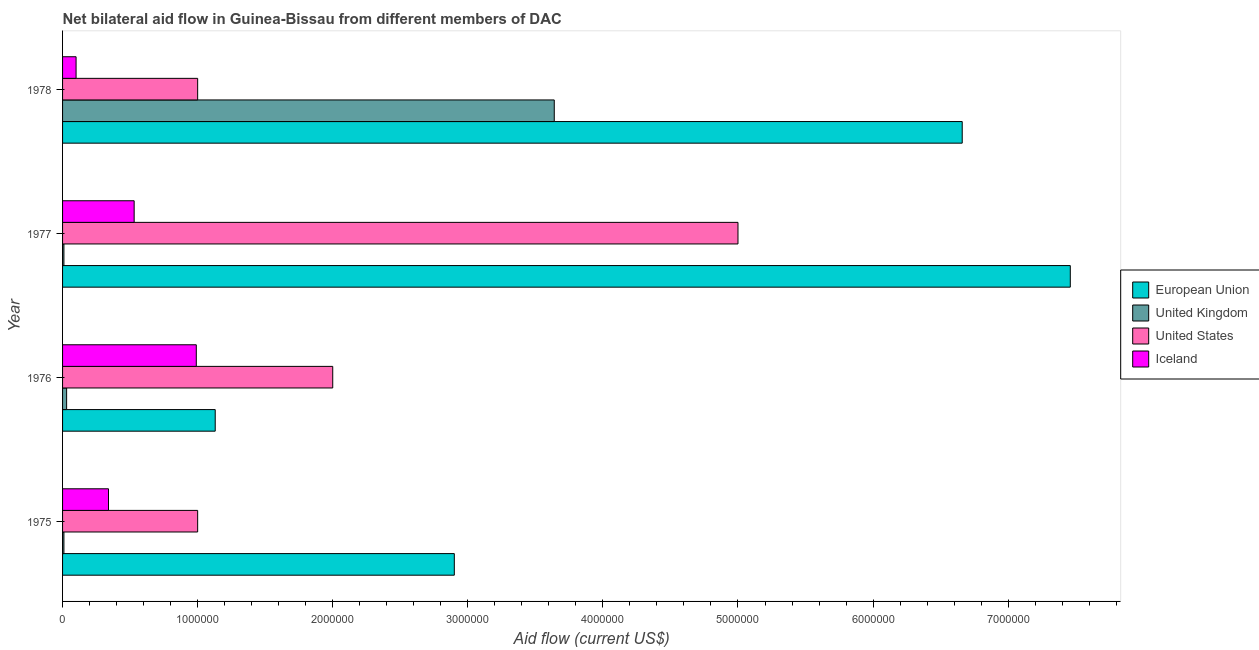How many different coloured bars are there?
Keep it short and to the point. 4. Are the number of bars per tick equal to the number of legend labels?
Keep it short and to the point. Yes. Are the number of bars on each tick of the Y-axis equal?
Make the answer very short. Yes. How many bars are there on the 1st tick from the top?
Make the answer very short. 4. How many bars are there on the 3rd tick from the bottom?
Your answer should be very brief. 4. What is the label of the 3rd group of bars from the top?
Your response must be concise. 1976. What is the amount of aid given by uk in 1975?
Ensure brevity in your answer.  10000. Across all years, what is the maximum amount of aid given by eu?
Your answer should be compact. 7.46e+06. Across all years, what is the minimum amount of aid given by us?
Offer a very short reply. 1.00e+06. In which year was the amount of aid given by uk maximum?
Offer a very short reply. 1978. In which year was the amount of aid given by uk minimum?
Ensure brevity in your answer.  1975. What is the total amount of aid given by eu in the graph?
Offer a terse response. 1.82e+07. What is the difference between the amount of aid given by us in 1977 and that in 1978?
Provide a succinct answer. 4.00e+06. What is the difference between the amount of aid given by eu in 1977 and the amount of aid given by iceland in 1978?
Your answer should be compact. 7.36e+06. In the year 1976, what is the difference between the amount of aid given by us and amount of aid given by eu?
Your answer should be very brief. 8.70e+05. What is the ratio of the amount of aid given by uk in 1977 to that in 1978?
Offer a very short reply. 0. Is the difference between the amount of aid given by uk in 1976 and 1977 greater than the difference between the amount of aid given by iceland in 1976 and 1977?
Keep it short and to the point. No. What is the difference between the highest and the second highest amount of aid given by us?
Provide a succinct answer. 3.00e+06. What is the difference between the highest and the lowest amount of aid given by eu?
Ensure brevity in your answer.  6.33e+06. Is it the case that in every year, the sum of the amount of aid given by us and amount of aid given by uk is greater than the sum of amount of aid given by iceland and amount of aid given by eu?
Your answer should be compact. No. What does the 4th bar from the top in 1978 represents?
Offer a very short reply. European Union. What does the 1st bar from the bottom in 1976 represents?
Make the answer very short. European Union. Is it the case that in every year, the sum of the amount of aid given by eu and amount of aid given by uk is greater than the amount of aid given by us?
Provide a succinct answer. No. Are all the bars in the graph horizontal?
Offer a terse response. Yes. Are the values on the major ticks of X-axis written in scientific E-notation?
Provide a succinct answer. No. Does the graph contain grids?
Make the answer very short. No. What is the title of the graph?
Provide a succinct answer. Net bilateral aid flow in Guinea-Bissau from different members of DAC. What is the Aid flow (current US$) in European Union in 1975?
Keep it short and to the point. 2.90e+06. What is the Aid flow (current US$) of United Kingdom in 1975?
Keep it short and to the point. 10000. What is the Aid flow (current US$) in United States in 1975?
Provide a succinct answer. 1.00e+06. What is the Aid flow (current US$) of Iceland in 1975?
Make the answer very short. 3.40e+05. What is the Aid flow (current US$) of European Union in 1976?
Your response must be concise. 1.13e+06. What is the Aid flow (current US$) in Iceland in 1976?
Provide a succinct answer. 9.90e+05. What is the Aid flow (current US$) in European Union in 1977?
Provide a succinct answer. 7.46e+06. What is the Aid flow (current US$) in Iceland in 1977?
Your answer should be very brief. 5.30e+05. What is the Aid flow (current US$) of European Union in 1978?
Provide a short and direct response. 6.66e+06. What is the Aid flow (current US$) in United Kingdom in 1978?
Keep it short and to the point. 3.64e+06. What is the Aid flow (current US$) of United States in 1978?
Ensure brevity in your answer.  1.00e+06. Across all years, what is the maximum Aid flow (current US$) in European Union?
Provide a short and direct response. 7.46e+06. Across all years, what is the maximum Aid flow (current US$) in United Kingdom?
Ensure brevity in your answer.  3.64e+06. Across all years, what is the maximum Aid flow (current US$) in Iceland?
Your answer should be compact. 9.90e+05. Across all years, what is the minimum Aid flow (current US$) of European Union?
Your response must be concise. 1.13e+06. Across all years, what is the minimum Aid flow (current US$) in United Kingdom?
Make the answer very short. 10000. Across all years, what is the minimum Aid flow (current US$) of United States?
Offer a terse response. 1.00e+06. What is the total Aid flow (current US$) in European Union in the graph?
Offer a very short reply. 1.82e+07. What is the total Aid flow (current US$) of United Kingdom in the graph?
Ensure brevity in your answer.  3.69e+06. What is the total Aid flow (current US$) of United States in the graph?
Your answer should be compact. 9.00e+06. What is the total Aid flow (current US$) in Iceland in the graph?
Your answer should be very brief. 1.96e+06. What is the difference between the Aid flow (current US$) in European Union in 1975 and that in 1976?
Provide a succinct answer. 1.77e+06. What is the difference between the Aid flow (current US$) of United States in 1975 and that in 1976?
Your response must be concise. -1.00e+06. What is the difference between the Aid flow (current US$) of Iceland in 1975 and that in 1976?
Your answer should be very brief. -6.50e+05. What is the difference between the Aid flow (current US$) of European Union in 1975 and that in 1977?
Give a very brief answer. -4.56e+06. What is the difference between the Aid flow (current US$) of United States in 1975 and that in 1977?
Your response must be concise. -4.00e+06. What is the difference between the Aid flow (current US$) in Iceland in 1975 and that in 1977?
Make the answer very short. -1.90e+05. What is the difference between the Aid flow (current US$) in European Union in 1975 and that in 1978?
Offer a very short reply. -3.76e+06. What is the difference between the Aid flow (current US$) in United Kingdom in 1975 and that in 1978?
Provide a succinct answer. -3.63e+06. What is the difference between the Aid flow (current US$) of United States in 1975 and that in 1978?
Your answer should be very brief. 0. What is the difference between the Aid flow (current US$) of Iceland in 1975 and that in 1978?
Offer a very short reply. 2.40e+05. What is the difference between the Aid flow (current US$) of European Union in 1976 and that in 1977?
Offer a terse response. -6.33e+06. What is the difference between the Aid flow (current US$) in United Kingdom in 1976 and that in 1977?
Offer a terse response. 2.00e+04. What is the difference between the Aid flow (current US$) of United States in 1976 and that in 1977?
Keep it short and to the point. -3.00e+06. What is the difference between the Aid flow (current US$) of European Union in 1976 and that in 1978?
Offer a very short reply. -5.53e+06. What is the difference between the Aid flow (current US$) of United Kingdom in 1976 and that in 1978?
Provide a short and direct response. -3.61e+06. What is the difference between the Aid flow (current US$) of United States in 1976 and that in 1978?
Make the answer very short. 1.00e+06. What is the difference between the Aid flow (current US$) of Iceland in 1976 and that in 1978?
Ensure brevity in your answer.  8.90e+05. What is the difference between the Aid flow (current US$) of United Kingdom in 1977 and that in 1978?
Give a very brief answer. -3.63e+06. What is the difference between the Aid flow (current US$) of European Union in 1975 and the Aid flow (current US$) of United Kingdom in 1976?
Provide a short and direct response. 2.87e+06. What is the difference between the Aid flow (current US$) in European Union in 1975 and the Aid flow (current US$) in Iceland in 1976?
Give a very brief answer. 1.91e+06. What is the difference between the Aid flow (current US$) of United Kingdom in 1975 and the Aid flow (current US$) of United States in 1976?
Your answer should be very brief. -1.99e+06. What is the difference between the Aid flow (current US$) in United Kingdom in 1975 and the Aid flow (current US$) in Iceland in 1976?
Make the answer very short. -9.80e+05. What is the difference between the Aid flow (current US$) in European Union in 1975 and the Aid flow (current US$) in United Kingdom in 1977?
Your answer should be very brief. 2.89e+06. What is the difference between the Aid flow (current US$) of European Union in 1975 and the Aid flow (current US$) of United States in 1977?
Your answer should be compact. -2.10e+06. What is the difference between the Aid flow (current US$) of European Union in 1975 and the Aid flow (current US$) of Iceland in 1977?
Make the answer very short. 2.37e+06. What is the difference between the Aid flow (current US$) in United Kingdom in 1975 and the Aid flow (current US$) in United States in 1977?
Keep it short and to the point. -4.99e+06. What is the difference between the Aid flow (current US$) of United Kingdom in 1975 and the Aid flow (current US$) of Iceland in 1977?
Make the answer very short. -5.20e+05. What is the difference between the Aid flow (current US$) in United States in 1975 and the Aid flow (current US$) in Iceland in 1977?
Your answer should be compact. 4.70e+05. What is the difference between the Aid flow (current US$) of European Union in 1975 and the Aid flow (current US$) of United Kingdom in 1978?
Give a very brief answer. -7.40e+05. What is the difference between the Aid flow (current US$) in European Union in 1975 and the Aid flow (current US$) in United States in 1978?
Offer a terse response. 1.90e+06. What is the difference between the Aid flow (current US$) in European Union in 1975 and the Aid flow (current US$) in Iceland in 1978?
Offer a very short reply. 2.80e+06. What is the difference between the Aid flow (current US$) of United Kingdom in 1975 and the Aid flow (current US$) of United States in 1978?
Provide a short and direct response. -9.90e+05. What is the difference between the Aid flow (current US$) of United Kingdom in 1975 and the Aid flow (current US$) of Iceland in 1978?
Keep it short and to the point. -9.00e+04. What is the difference between the Aid flow (current US$) in European Union in 1976 and the Aid flow (current US$) in United Kingdom in 1977?
Offer a very short reply. 1.12e+06. What is the difference between the Aid flow (current US$) of European Union in 1976 and the Aid flow (current US$) of United States in 1977?
Your response must be concise. -3.87e+06. What is the difference between the Aid flow (current US$) in European Union in 1976 and the Aid flow (current US$) in Iceland in 1977?
Offer a terse response. 6.00e+05. What is the difference between the Aid flow (current US$) in United Kingdom in 1976 and the Aid flow (current US$) in United States in 1977?
Keep it short and to the point. -4.97e+06. What is the difference between the Aid flow (current US$) in United Kingdom in 1976 and the Aid flow (current US$) in Iceland in 1977?
Your answer should be compact. -5.00e+05. What is the difference between the Aid flow (current US$) in United States in 1976 and the Aid flow (current US$) in Iceland in 1977?
Provide a short and direct response. 1.47e+06. What is the difference between the Aid flow (current US$) of European Union in 1976 and the Aid flow (current US$) of United Kingdom in 1978?
Offer a very short reply. -2.51e+06. What is the difference between the Aid flow (current US$) of European Union in 1976 and the Aid flow (current US$) of Iceland in 1978?
Ensure brevity in your answer.  1.03e+06. What is the difference between the Aid flow (current US$) of United Kingdom in 1976 and the Aid flow (current US$) of United States in 1978?
Your response must be concise. -9.70e+05. What is the difference between the Aid flow (current US$) in United Kingdom in 1976 and the Aid flow (current US$) in Iceland in 1978?
Provide a short and direct response. -7.00e+04. What is the difference between the Aid flow (current US$) in United States in 1976 and the Aid flow (current US$) in Iceland in 1978?
Give a very brief answer. 1.90e+06. What is the difference between the Aid flow (current US$) in European Union in 1977 and the Aid flow (current US$) in United Kingdom in 1978?
Ensure brevity in your answer.  3.82e+06. What is the difference between the Aid flow (current US$) in European Union in 1977 and the Aid flow (current US$) in United States in 1978?
Provide a short and direct response. 6.46e+06. What is the difference between the Aid flow (current US$) of European Union in 1977 and the Aid flow (current US$) of Iceland in 1978?
Keep it short and to the point. 7.36e+06. What is the difference between the Aid flow (current US$) of United Kingdom in 1977 and the Aid flow (current US$) of United States in 1978?
Your answer should be very brief. -9.90e+05. What is the difference between the Aid flow (current US$) of United Kingdom in 1977 and the Aid flow (current US$) of Iceland in 1978?
Your answer should be compact. -9.00e+04. What is the difference between the Aid flow (current US$) in United States in 1977 and the Aid flow (current US$) in Iceland in 1978?
Your answer should be compact. 4.90e+06. What is the average Aid flow (current US$) of European Union per year?
Ensure brevity in your answer.  4.54e+06. What is the average Aid flow (current US$) in United Kingdom per year?
Give a very brief answer. 9.22e+05. What is the average Aid flow (current US$) in United States per year?
Make the answer very short. 2.25e+06. What is the average Aid flow (current US$) of Iceland per year?
Provide a succinct answer. 4.90e+05. In the year 1975, what is the difference between the Aid flow (current US$) of European Union and Aid flow (current US$) of United Kingdom?
Give a very brief answer. 2.89e+06. In the year 1975, what is the difference between the Aid flow (current US$) in European Union and Aid flow (current US$) in United States?
Ensure brevity in your answer.  1.90e+06. In the year 1975, what is the difference between the Aid flow (current US$) in European Union and Aid flow (current US$) in Iceland?
Offer a very short reply. 2.56e+06. In the year 1975, what is the difference between the Aid flow (current US$) in United Kingdom and Aid flow (current US$) in United States?
Provide a short and direct response. -9.90e+05. In the year 1975, what is the difference between the Aid flow (current US$) in United Kingdom and Aid flow (current US$) in Iceland?
Provide a short and direct response. -3.30e+05. In the year 1976, what is the difference between the Aid flow (current US$) in European Union and Aid flow (current US$) in United Kingdom?
Offer a terse response. 1.10e+06. In the year 1976, what is the difference between the Aid flow (current US$) in European Union and Aid flow (current US$) in United States?
Your answer should be compact. -8.70e+05. In the year 1976, what is the difference between the Aid flow (current US$) in European Union and Aid flow (current US$) in Iceland?
Your answer should be very brief. 1.40e+05. In the year 1976, what is the difference between the Aid flow (current US$) in United Kingdom and Aid flow (current US$) in United States?
Offer a terse response. -1.97e+06. In the year 1976, what is the difference between the Aid flow (current US$) of United Kingdom and Aid flow (current US$) of Iceland?
Give a very brief answer. -9.60e+05. In the year 1976, what is the difference between the Aid flow (current US$) of United States and Aid flow (current US$) of Iceland?
Provide a short and direct response. 1.01e+06. In the year 1977, what is the difference between the Aid flow (current US$) of European Union and Aid flow (current US$) of United Kingdom?
Your answer should be compact. 7.45e+06. In the year 1977, what is the difference between the Aid flow (current US$) of European Union and Aid flow (current US$) of United States?
Give a very brief answer. 2.46e+06. In the year 1977, what is the difference between the Aid flow (current US$) in European Union and Aid flow (current US$) in Iceland?
Your answer should be very brief. 6.93e+06. In the year 1977, what is the difference between the Aid flow (current US$) of United Kingdom and Aid flow (current US$) of United States?
Offer a very short reply. -4.99e+06. In the year 1977, what is the difference between the Aid flow (current US$) of United Kingdom and Aid flow (current US$) of Iceland?
Ensure brevity in your answer.  -5.20e+05. In the year 1977, what is the difference between the Aid flow (current US$) in United States and Aid flow (current US$) in Iceland?
Your response must be concise. 4.47e+06. In the year 1978, what is the difference between the Aid flow (current US$) of European Union and Aid flow (current US$) of United Kingdom?
Your answer should be compact. 3.02e+06. In the year 1978, what is the difference between the Aid flow (current US$) in European Union and Aid flow (current US$) in United States?
Your response must be concise. 5.66e+06. In the year 1978, what is the difference between the Aid flow (current US$) in European Union and Aid flow (current US$) in Iceland?
Offer a terse response. 6.56e+06. In the year 1978, what is the difference between the Aid flow (current US$) of United Kingdom and Aid flow (current US$) of United States?
Your answer should be very brief. 2.64e+06. In the year 1978, what is the difference between the Aid flow (current US$) in United Kingdom and Aid flow (current US$) in Iceland?
Make the answer very short. 3.54e+06. What is the ratio of the Aid flow (current US$) in European Union in 1975 to that in 1976?
Make the answer very short. 2.57. What is the ratio of the Aid flow (current US$) of United Kingdom in 1975 to that in 1976?
Offer a terse response. 0.33. What is the ratio of the Aid flow (current US$) of United States in 1975 to that in 1976?
Provide a succinct answer. 0.5. What is the ratio of the Aid flow (current US$) of Iceland in 1975 to that in 1976?
Make the answer very short. 0.34. What is the ratio of the Aid flow (current US$) of European Union in 1975 to that in 1977?
Your response must be concise. 0.39. What is the ratio of the Aid flow (current US$) of Iceland in 1975 to that in 1977?
Ensure brevity in your answer.  0.64. What is the ratio of the Aid flow (current US$) of European Union in 1975 to that in 1978?
Your answer should be very brief. 0.44. What is the ratio of the Aid flow (current US$) in United Kingdom in 1975 to that in 1978?
Give a very brief answer. 0. What is the ratio of the Aid flow (current US$) of Iceland in 1975 to that in 1978?
Keep it short and to the point. 3.4. What is the ratio of the Aid flow (current US$) of European Union in 1976 to that in 1977?
Ensure brevity in your answer.  0.15. What is the ratio of the Aid flow (current US$) in United States in 1976 to that in 1977?
Make the answer very short. 0.4. What is the ratio of the Aid flow (current US$) in Iceland in 1976 to that in 1977?
Your response must be concise. 1.87. What is the ratio of the Aid flow (current US$) in European Union in 1976 to that in 1978?
Keep it short and to the point. 0.17. What is the ratio of the Aid flow (current US$) in United Kingdom in 1976 to that in 1978?
Your response must be concise. 0.01. What is the ratio of the Aid flow (current US$) of United States in 1976 to that in 1978?
Give a very brief answer. 2. What is the ratio of the Aid flow (current US$) of Iceland in 1976 to that in 1978?
Offer a very short reply. 9.9. What is the ratio of the Aid flow (current US$) of European Union in 1977 to that in 1978?
Your answer should be compact. 1.12. What is the ratio of the Aid flow (current US$) in United Kingdom in 1977 to that in 1978?
Your response must be concise. 0. What is the ratio of the Aid flow (current US$) of United States in 1977 to that in 1978?
Your response must be concise. 5. What is the difference between the highest and the second highest Aid flow (current US$) in European Union?
Offer a terse response. 8.00e+05. What is the difference between the highest and the second highest Aid flow (current US$) in United Kingdom?
Your answer should be compact. 3.61e+06. What is the difference between the highest and the second highest Aid flow (current US$) of United States?
Ensure brevity in your answer.  3.00e+06. What is the difference between the highest and the second highest Aid flow (current US$) of Iceland?
Ensure brevity in your answer.  4.60e+05. What is the difference between the highest and the lowest Aid flow (current US$) in European Union?
Give a very brief answer. 6.33e+06. What is the difference between the highest and the lowest Aid flow (current US$) in United Kingdom?
Provide a short and direct response. 3.63e+06. What is the difference between the highest and the lowest Aid flow (current US$) in United States?
Your answer should be compact. 4.00e+06. What is the difference between the highest and the lowest Aid flow (current US$) in Iceland?
Your response must be concise. 8.90e+05. 